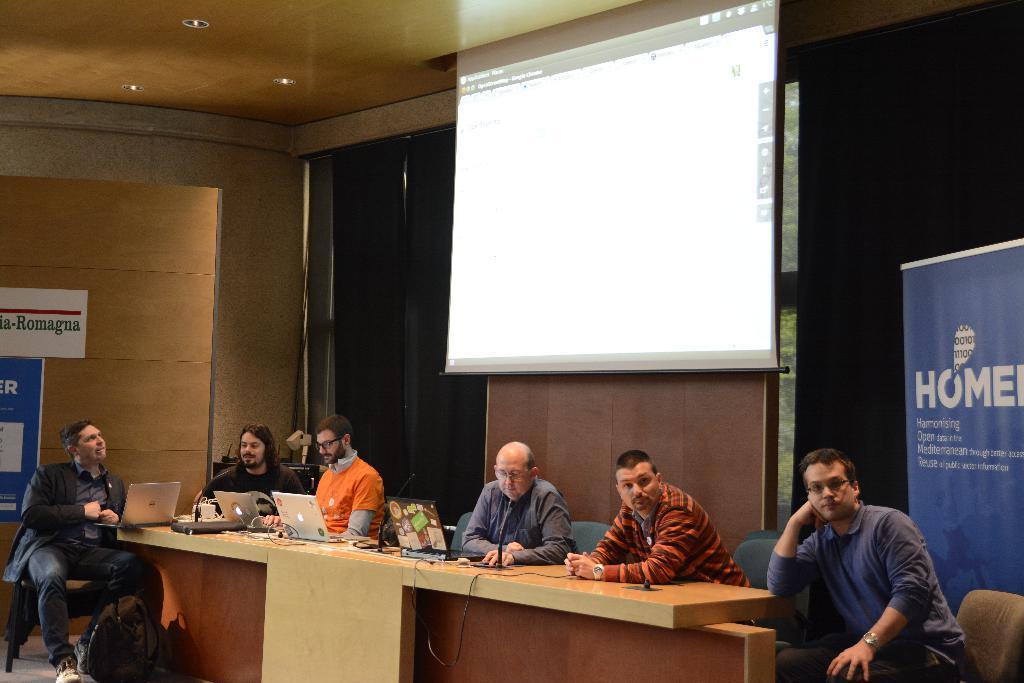Can you describe this image briefly? In this image i can see a group of people sitting on the chair. On the table we can see there are few laptops and a microphone and a few other stuff. In the background of the image we can see a projector screen and on the right side of the image we can see a banner. 